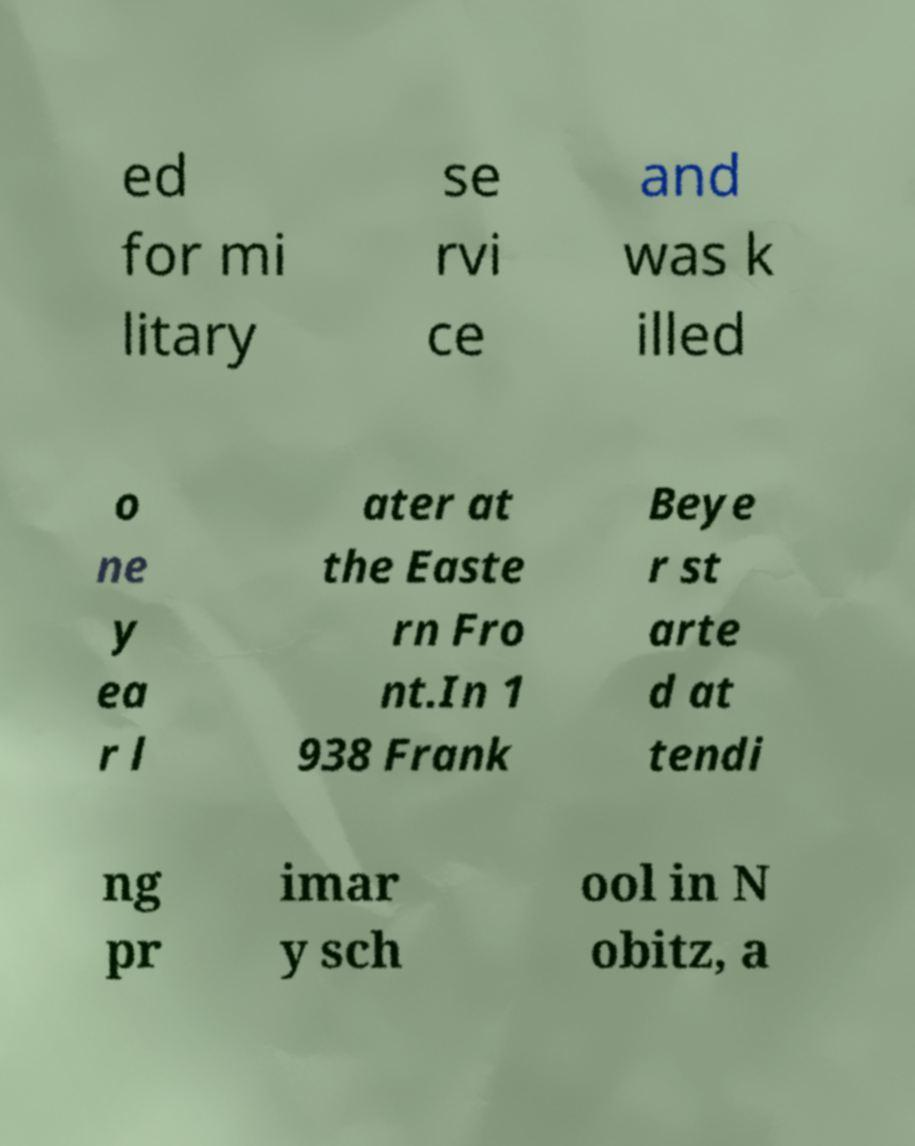Could you assist in decoding the text presented in this image and type it out clearly? ed for mi litary se rvi ce and was k illed o ne y ea r l ater at the Easte rn Fro nt.In 1 938 Frank Beye r st arte d at tendi ng pr imar y sch ool in N obitz, a 